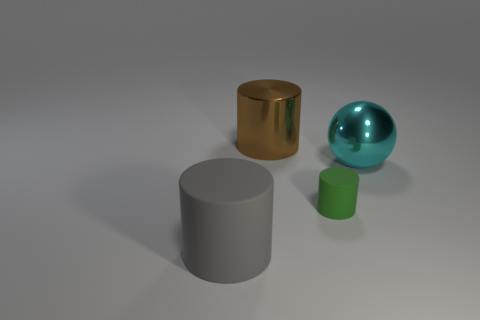What color is the shiny object that is on the right side of the matte cylinder that is behind the cylinder left of the large brown shiny cylinder?
Provide a short and direct response. Cyan. What number of cylinders are both in front of the shiny cylinder and behind the gray matte thing?
Ensure brevity in your answer.  1. What number of matte objects are either big brown balls or tiny cylinders?
Your answer should be compact. 1. What is the material of the large object to the right of the big cylinder behind the large gray matte thing?
Provide a succinct answer. Metal. What shape is the cyan thing that is the same size as the gray cylinder?
Ensure brevity in your answer.  Sphere. Are there fewer large things than things?
Your answer should be compact. Yes. There is a object in front of the tiny matte thing; is there a matte cylinder on the right side of it?
Offer a very short reply. Yes. There is another large thing that is the same material as the cyan thing; what is its shape?
Provide a succinct answer. Cylinder. What is the material of the big gray thing that is the same shape as the tiny object?
Offer a very short reply. Rubber. How many other objects are there of the same size as the green matte cylinder?
Your response must be concise. 0. 